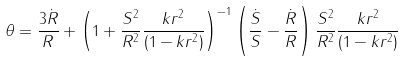<formula> <loc_0><loc_0><loc_500><loc_500>\theta = \frac { 3 \dot { R } } { R } + \left ( 1 + \frac { S ^ { 2 } } { R ^ { 2 } } \frac { k r ^ { 2 } } { ( 1 - k r ^ { 2 } ) } \right ) ^ { - 1 } \left ( \frac { \dot { S } } { S } - \frac { \dot { R } } { R } \right ) \frac { S ^ { 2 } } { R ^ { 2 } } \frac { k r ^ { 2 } } { ( 1 - k r ^ { 2 } ) }</formula> 